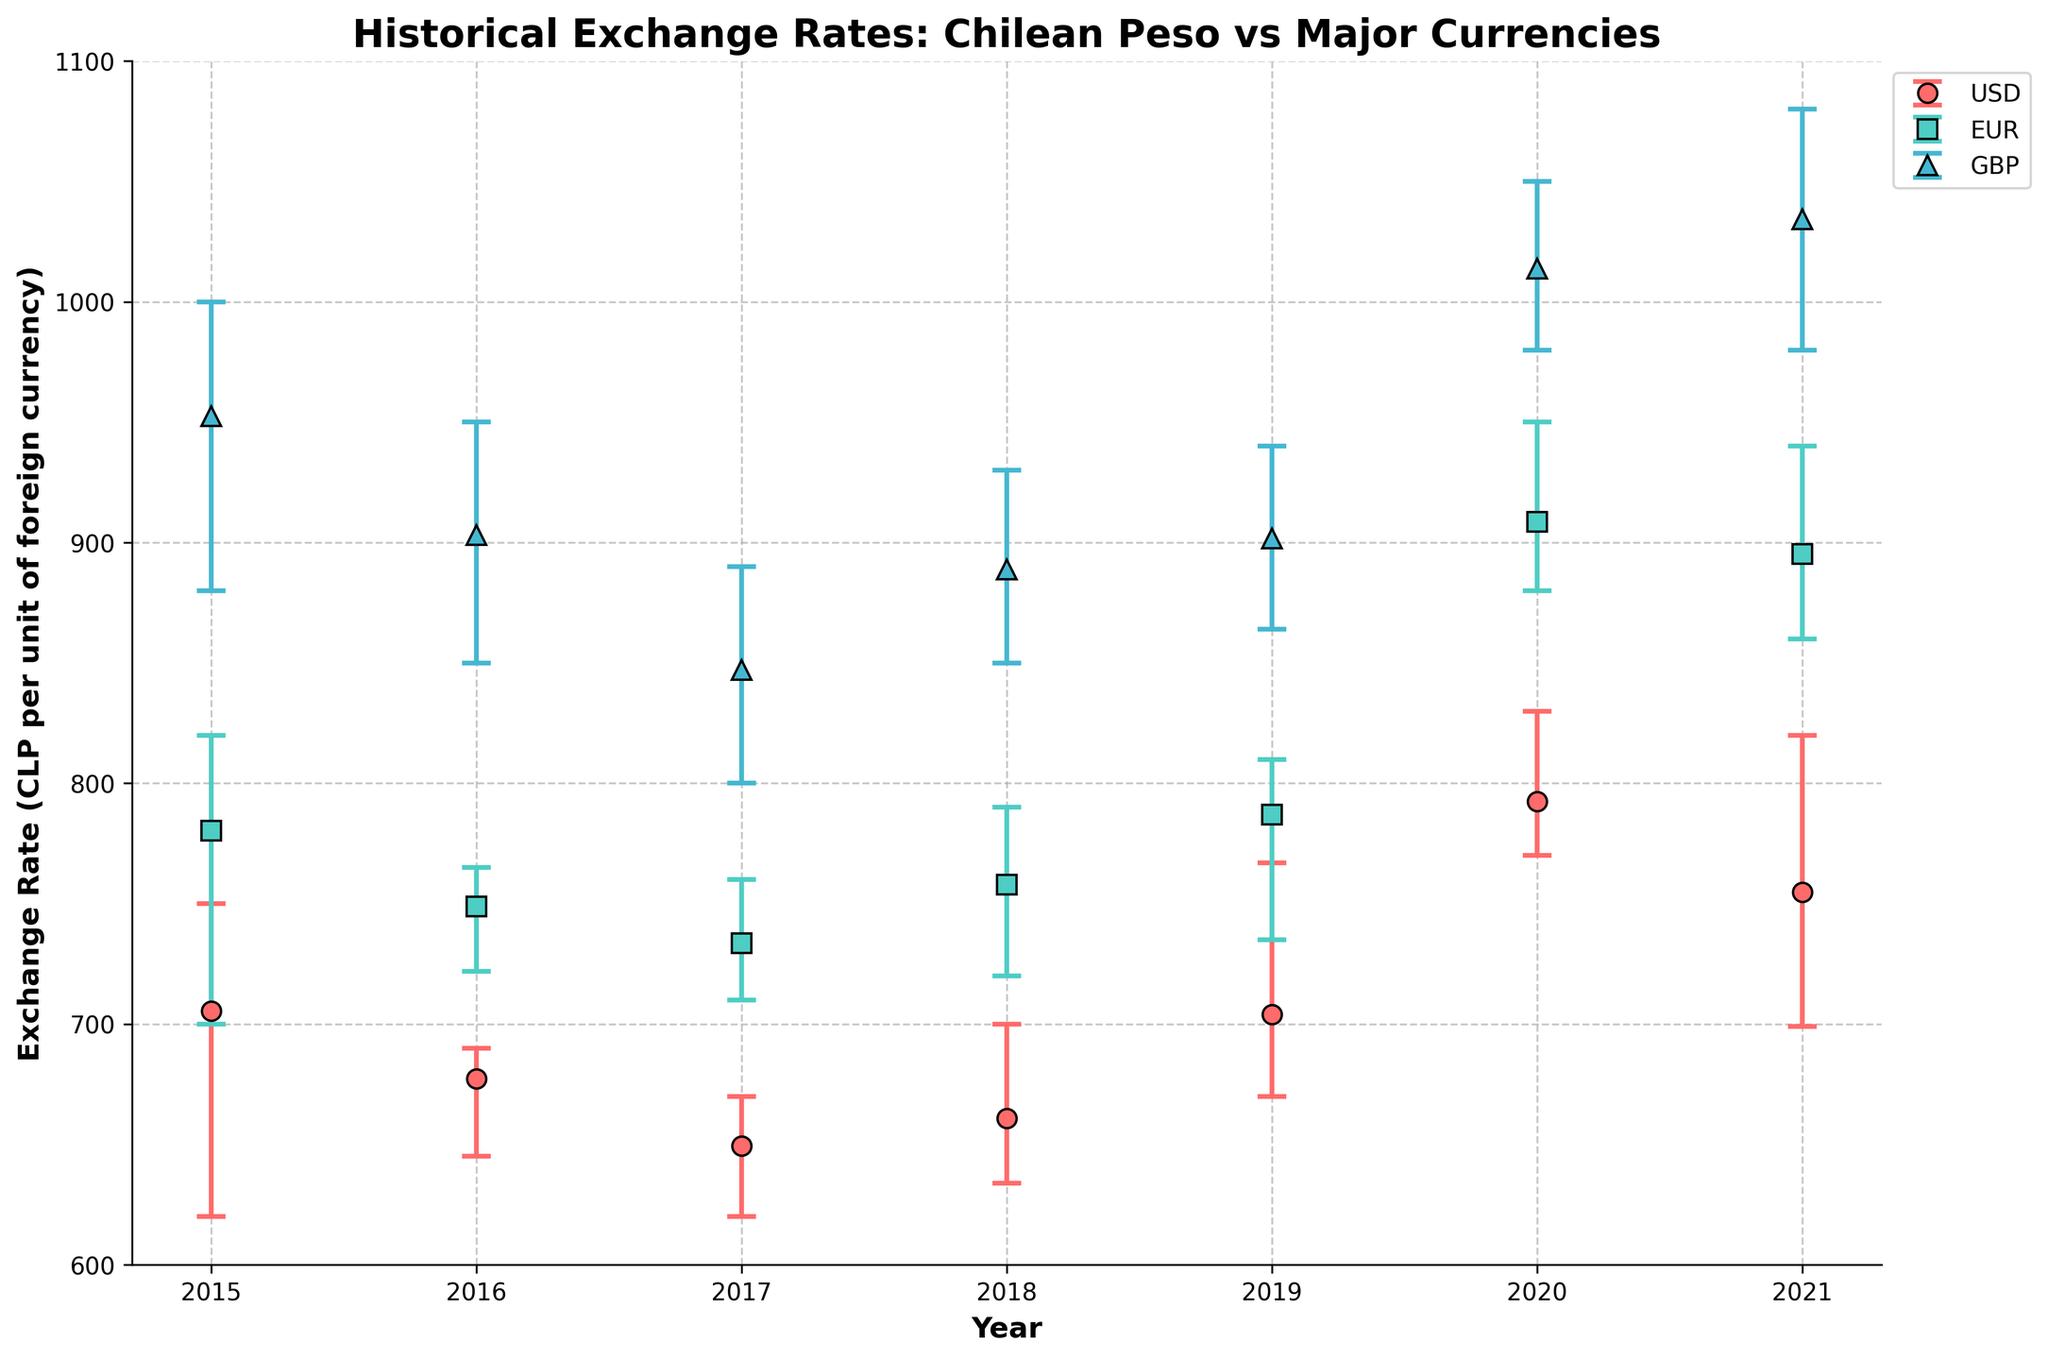What is the title of the figure? The title of the figure is usually found at the top of the chart; in this case, it describes the main topic of the visualization.
Answer: Historical Exchange Rates: Chilean Peso vs Major Currencies What is the average exchange rate for the USD in 2020? Locate the year 2020 on the x-axis and find the dot representing USD. The y-axis value corresponding to this dot gives the average exchange rate.
Answer: 792.50 Which currency had the highest average exchange rate in 2021? Look for the dots representing the year 2021 across all three currencies and identify the one with the highest y-axis value.
Answer: GBP Between which years did the USD see its lowest average exchange rate? Check the average rates along the y-axis for each year that USD dots are plotted, and find the year with the lowest value. The lowest point appears at its respective year on the x-axis.
Answer: 2017 What is the fluctuation range for the EUR in 2020? Find the error bar for EUR in 2020. Subtract the minimum rate from the maximum rate, as shown by the ends of the error bars.
Answer: 70 (950 - 880) How did the USD exchange rate change from 2019 to 2020? Compare the average exchange rates of USD for 2019 and 2020 by looking at their respective y-axis values. Calculate the difference.
Answer: Increased by 88.6 (792.5 - 703.9) Which year had the smallest fluctuation range for GBP? For each year that GBP is plotted, calculate the fluctuation range by subtracting the minimum value from the maximum value as indicated by the error bars. Then compare these ranges.
Answer: 2017 (890 - 800) Compare the average exchange rates of EUR and GBP in 2015. Which one was higher? Locate the dots for EUR and GBP in 2015 and compare their y-axis values to see which is higher.
Answer: GBP How did the fluctuation range of USD in 2018 compare to that in 2021? Calculate the fluctuation range for each year by subtracting the min value from the max value as indicated by the error bars, and then compare the range for the two years.
Answer: Decreased (2018: 66, 2021: 121) What's the trend of the average exchange rate for USD from 2015 to 2021? Observe the progression of the y-values of the USD dots from 2015 to 2021 to identify whether the rates generally increase, decrease, or stay constant.
Answer: Generally increasing 